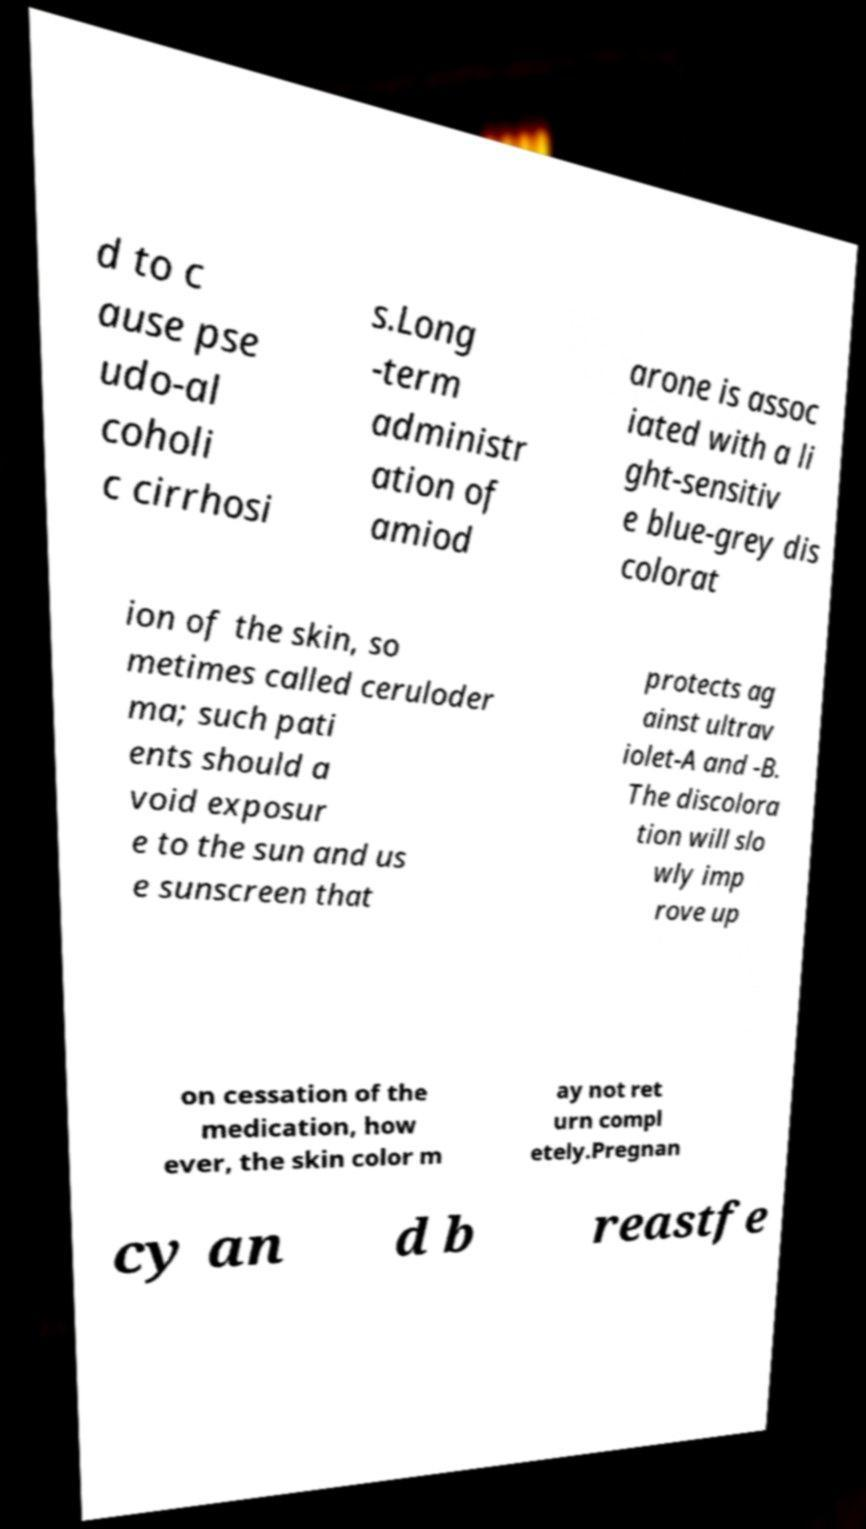For documentation purposes, I need the text within this image transcribed. Could you provide that? d to c ause pse udo-al coholi c cirrhosi s.Long -term administr ation of amiod arone is assoc iated with a li ght-sensitiv e blue-grey dis colorat ion of the skin, so metimes called ceruloder ma; such pati ents should a void exposur e to the sun and us e sunscreen that protects ag ainst ultrav iolet-A and -B. The discolora tion will slo wly imp rove up on cessation of the medication, how ever, the skin color m ay not ret urn compl etely.Pregnan cy an d b reastfe 